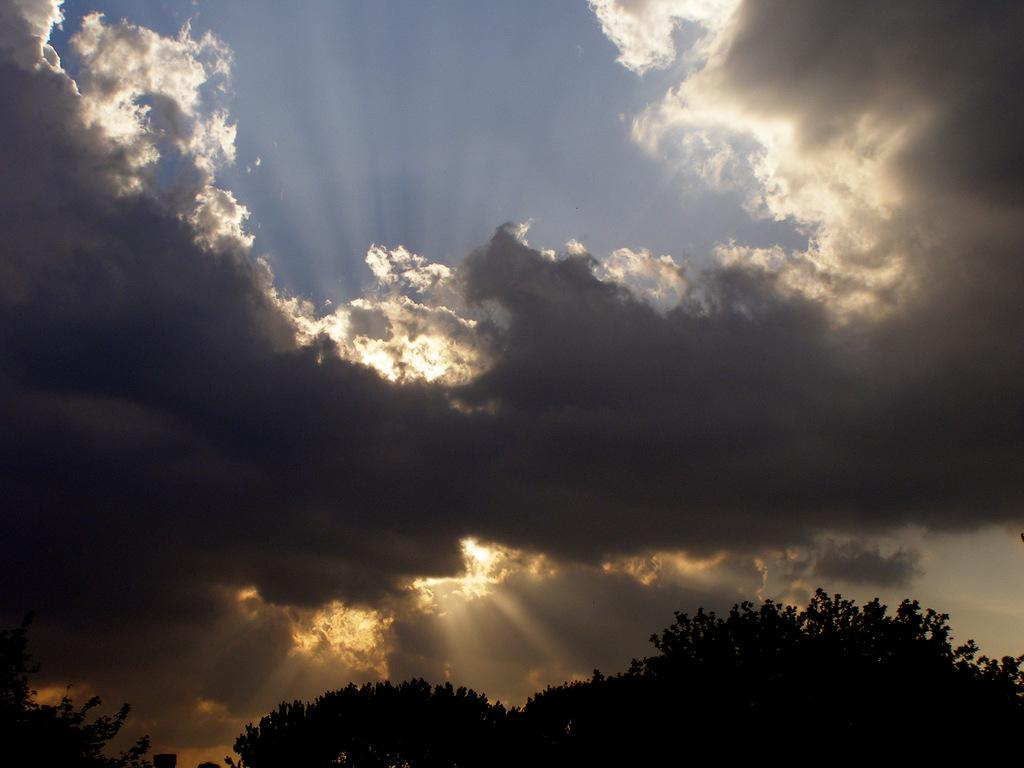What can be seen in the sky in the image? The sky is visible in the image. What is the sun's position in relation to the clouds in the image? The sun is hiding behind the clouds in the image. How would you describe the clouds in the image? The clouds are dark in the image. What type of vegetation is present on the ground in the image? There are trees on the ground in the image. Where is the shelf located in the image? There is no shelf present in the image. Can you describe the father's appearance in the image? There is no father present in the image. 